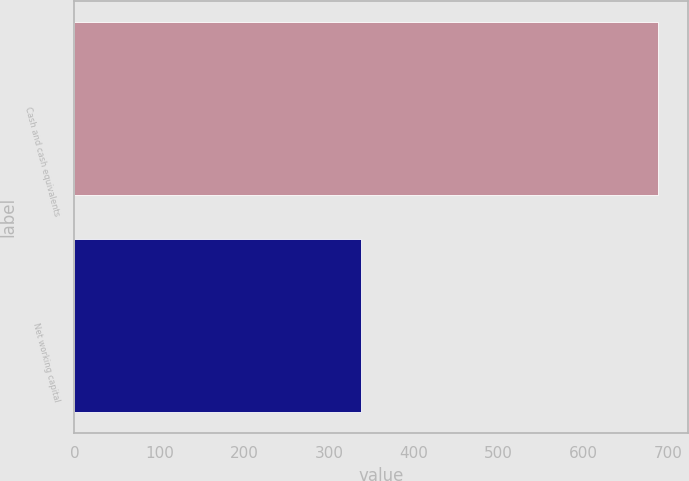Convert chart to OTSL. <chart><loc_0><loc_0><loc_500><loc_500><bar_chart><fcel>Cash and cash equivalents<fcel>Net working capital<nl><fcel>688.1<fcel>337.6<nl></chart> 